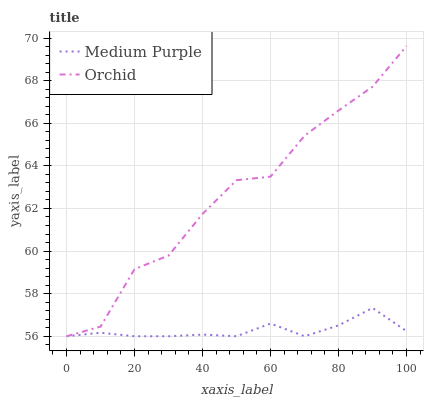Does Medium Purple have the minimum area under the curve?
Answer yes or no. Yes. Does Orchid have the maximum area under the curve?
Answer yes or no. Yes. Does Orchid have the minimum area under the curve?
Answer yes or no. No. Is Medium Purple the smoothest?
Answer yes or no. Yes. Is Orchid the roughest?
Answer yes or no. Yes. Is Orchid the smoothest?
Answer yes or no. No. Does Medium Purple have the lowest value?
Answer yes or no. Yes. Does Orchid have the highest value?
Answer yes or no. Yes. Does Medium Purple intersect Orchid?
Answer yes or no. Yes. Is Medium Purple less than Orchid?
Answer yes or no. No. Is Medium Purple greater than Orchid?
Answer yes or no. No. 